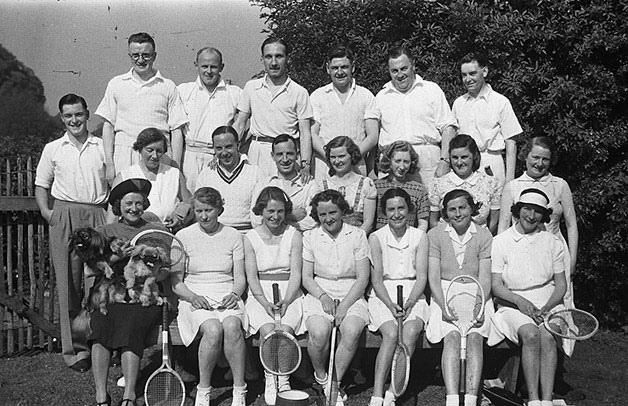Are all people the same gender?
Be succinct. No. How many countries are officially represented?
Be succinct. 1. Is anyone sitting?
Write a very short answer. Yes. Is the photo black and white?
Short answer required. Yes. Why is everyone wearing white?
Concise answer only. Uniform. Are all the people tennis players?
Write a very short answer. Yes. What game do these people play?
Write a very short answer. Tennis. 